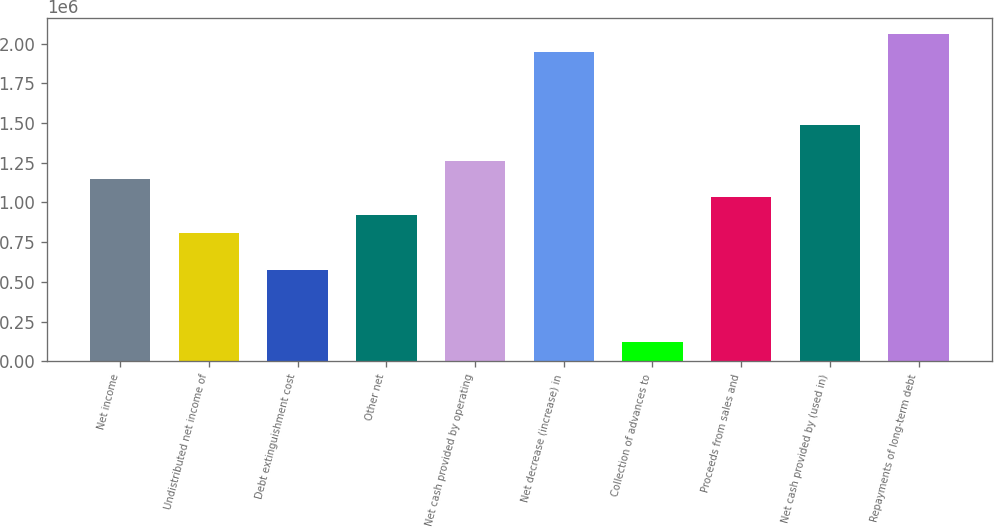<chart> <loc_0><loc_0><loc_500><loc_500><bar_chart><fcel>Net income<fcel>Undistributed net income of<fcel>Debt extinguishment cost<fcel>Other net<fcel>Net cash provided by operating<fcel>Net decrease (increase) in<fcel>Collection of advances to<fcel>Proceeds from sales and<fcel>Net cash provided by (used in)<fcel>Repayments of long-term debt<nl><fcel>1.14764e+06<fcel>805025<fcel>576615<fcel>919231<fcel>1.26185e+06<fcel>1.94708e+06<fcel>119794<fcel>1.03344e+06<fcel>1.49026e+06<fcel>2.06128e+06<nl></chart> 